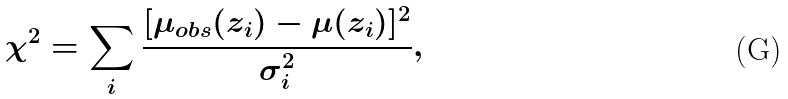<formula> <loc_0><loc_0><loc_500><loc_500>\chi ^ { 2 } = \sum _ { \substack { i } } \frac { [ \mu _ { o b s } ( z _ { i } ) - \mu ( z _ { i } ) ] ^ { 2 } } { \sigma ^ { 2 } _ { i } } ,</formula> 